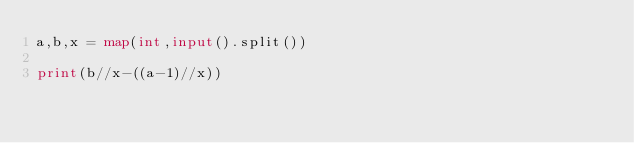<code> <loc_0><loc_0><loc_500><loc_500><_Python_>a,b,x = map(int,input().split())

print(b//x-((a-1)//x))</code> 